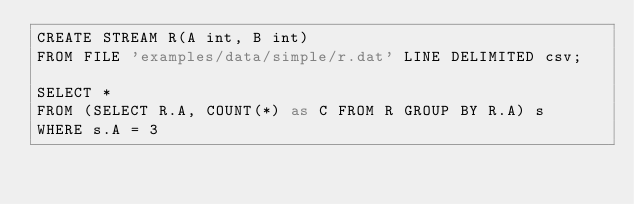<code> <loc_0><loc_0><loc_500><loc_500><_SQL_>CREATE STREAM R(A int, B int)
FROM FILE 'examples/data/simple/r.dat' LINE DELIMITED csv;

SELECT *
FROM (SELECT R.A, COUNT(*) as C FROM R GROUP BY R.A) s
WHERE s.A = 3
</code> 